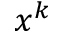<formula> <loc_0><loc_0><loc_500><loc_500>x ^ { k }</formula> 